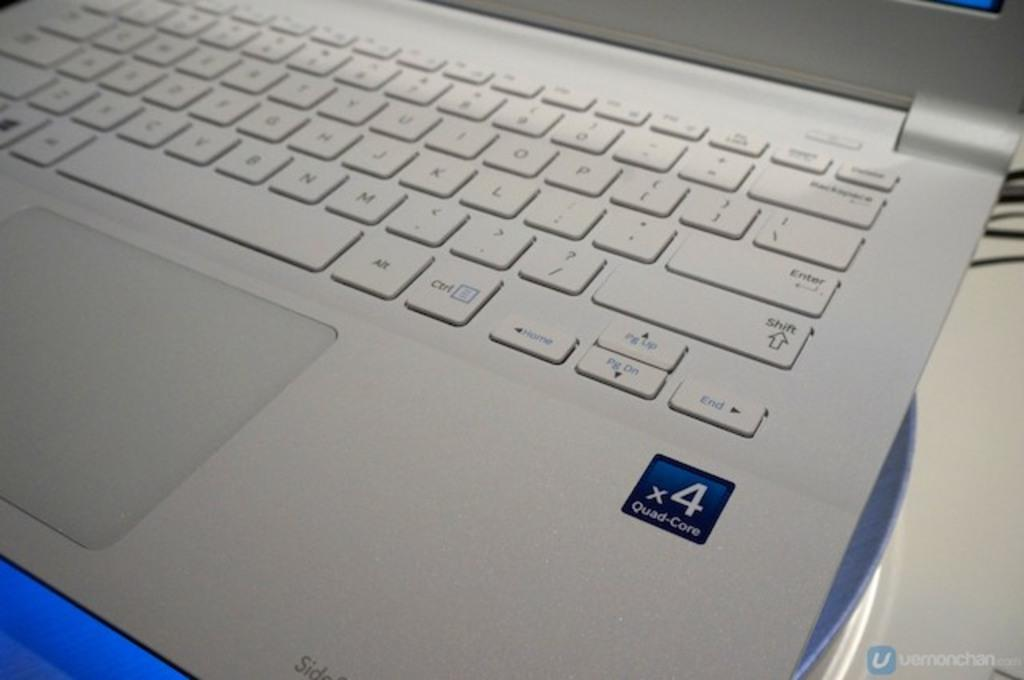Provide a one-sentence caption for the provided image. A white laptop that has a quad core processor. 